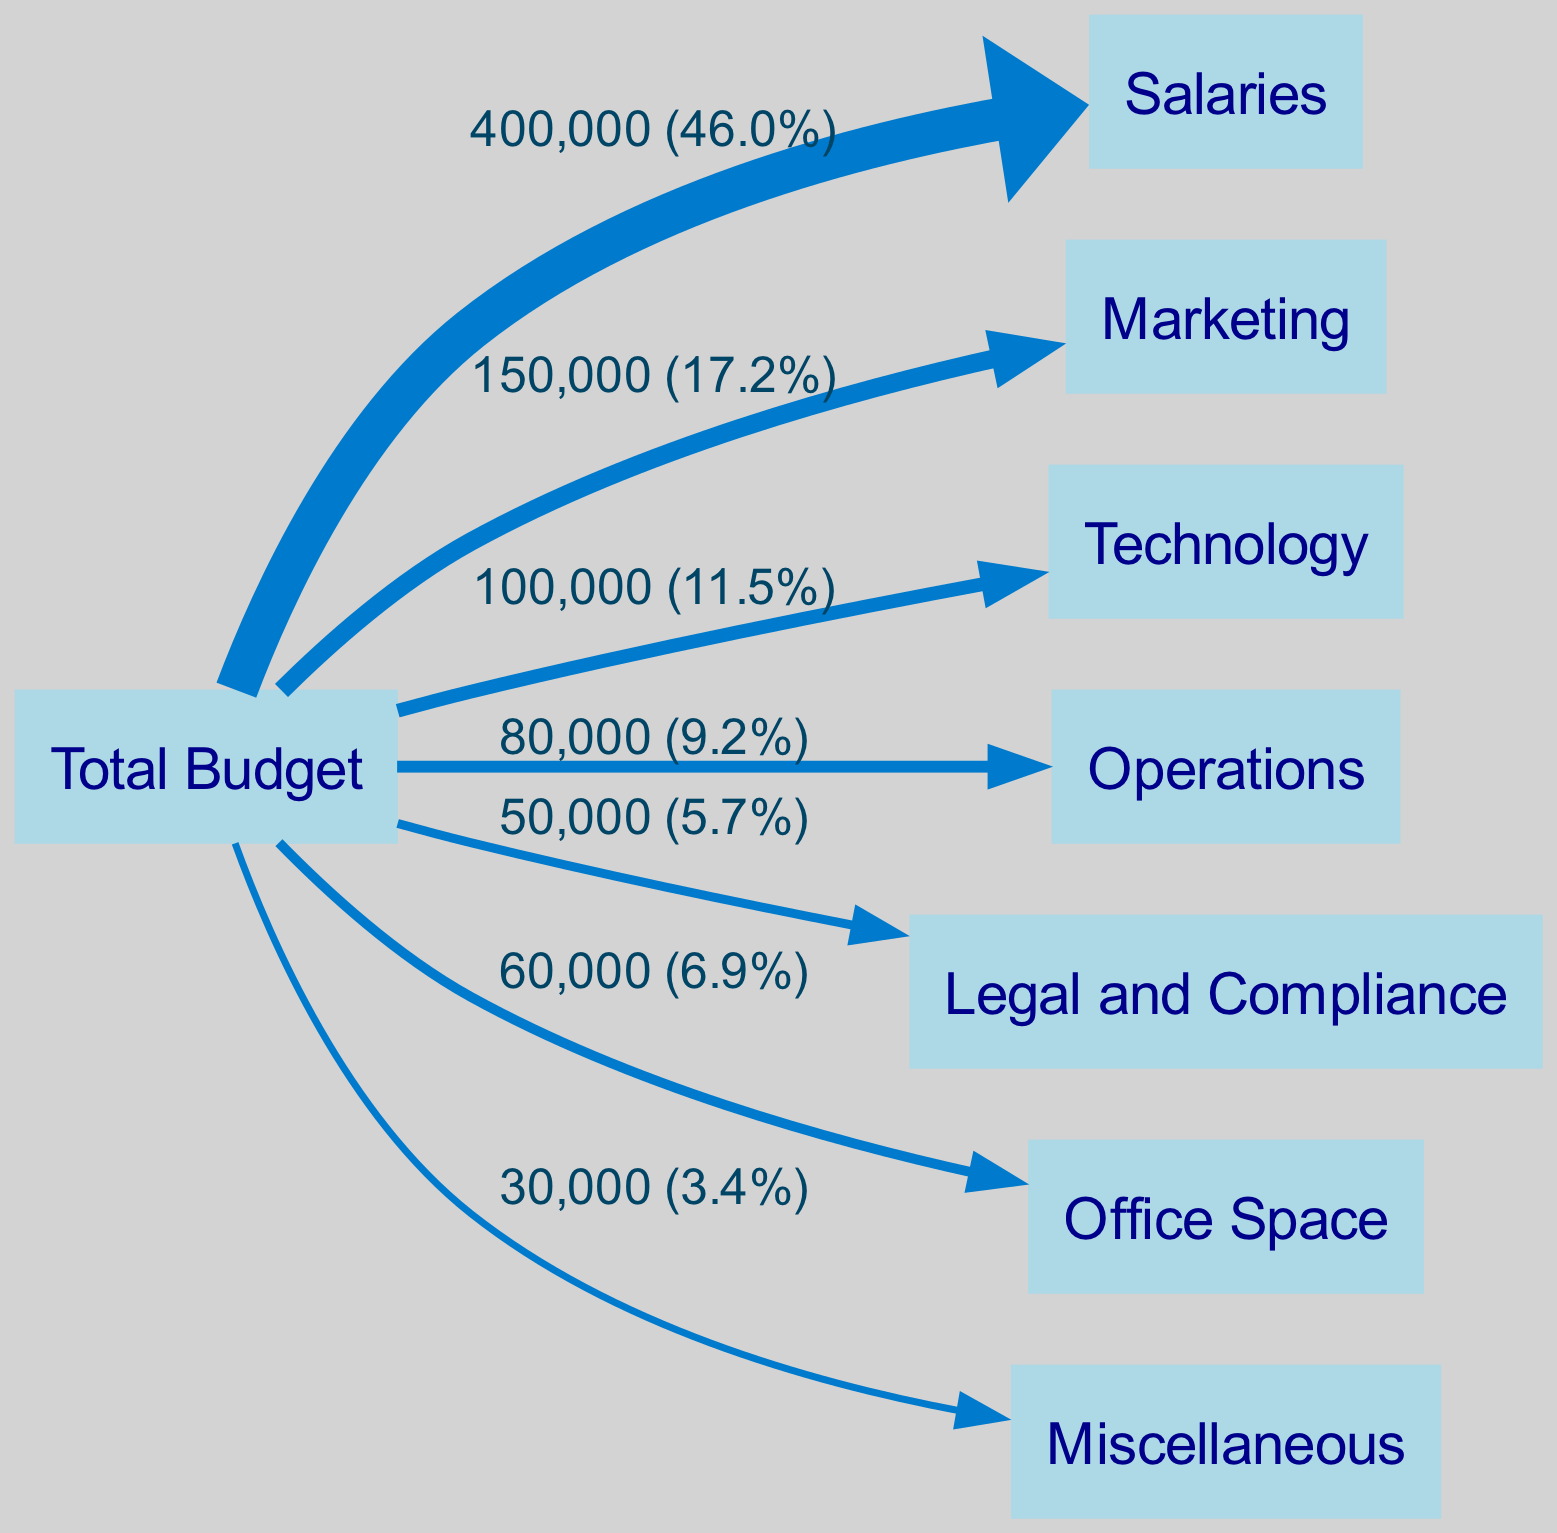What is the total budget for the tech startup? The total budget node is the source node representing the overall budget allocation. Based on the data links, the budget shown is equal to the sum of all expense categories, which adds up to 1,000,000 dollars.
Answer: 1,000,000 dollars How much is allocated to salaries? The salaries node links directly from the total budget node. The value indicated for salaries is 400,000 dollars, which is clearly shown in the diagram.
Answer: 400,000 dollars What is the percentage of the budget spent on marketing? The marketing node shows a value of 150,000 dollars. To find the percentage, we calculate (150,000 / 1,000,000) * 100, resulting in 15%.
Answer: 15% Which category has the highest allocation? By examining the links from the total budget, salaries have the highest value at 400,000 dollars compared to other categories. There is no need for further calculations since it's a direct comparison.
Answer: Salaries What is the total amount allocated to miscellaneous and legal and compliance combined? The miscellaneous category has a value of 30,000 dollars, and the legal and compliance category has a value of 50,000 dollars. By adding these two amounts, we get a total of 80,000 dollars.
Answer: 80,000 dollars Which category receives the least amount in budget allocation? Reviewing the links to identify the category with the lowest value shows that miscellaneous has the smallest allocation of 30,000 dollars.
Answer: Miscellaneous What is the combined total for technology and operations expenses? The technology category is allocated 100,000 dollars and the operations category is allocated 80,000 dollars. Adding these together gives us a total of 180,000 dollars.
Answer: 180,000 dollars How many total nodes are represented in the diagram? Counting all unique nodes in the diagram shows there are a total of 8 nodes, listed as the total budget and each of the expense categories.
Answer: 8 Which two categories have the smallest amounts compared to the total budget? Comparing the values of the nodes connected to the total budget, miscellaneous (30,000 dollars) and legal and compliance (50,000 dollars) are the smallest. This analysis requires examining each category's amount directly from the links.
Answer: Miscellaneous and Legal and Compliance 